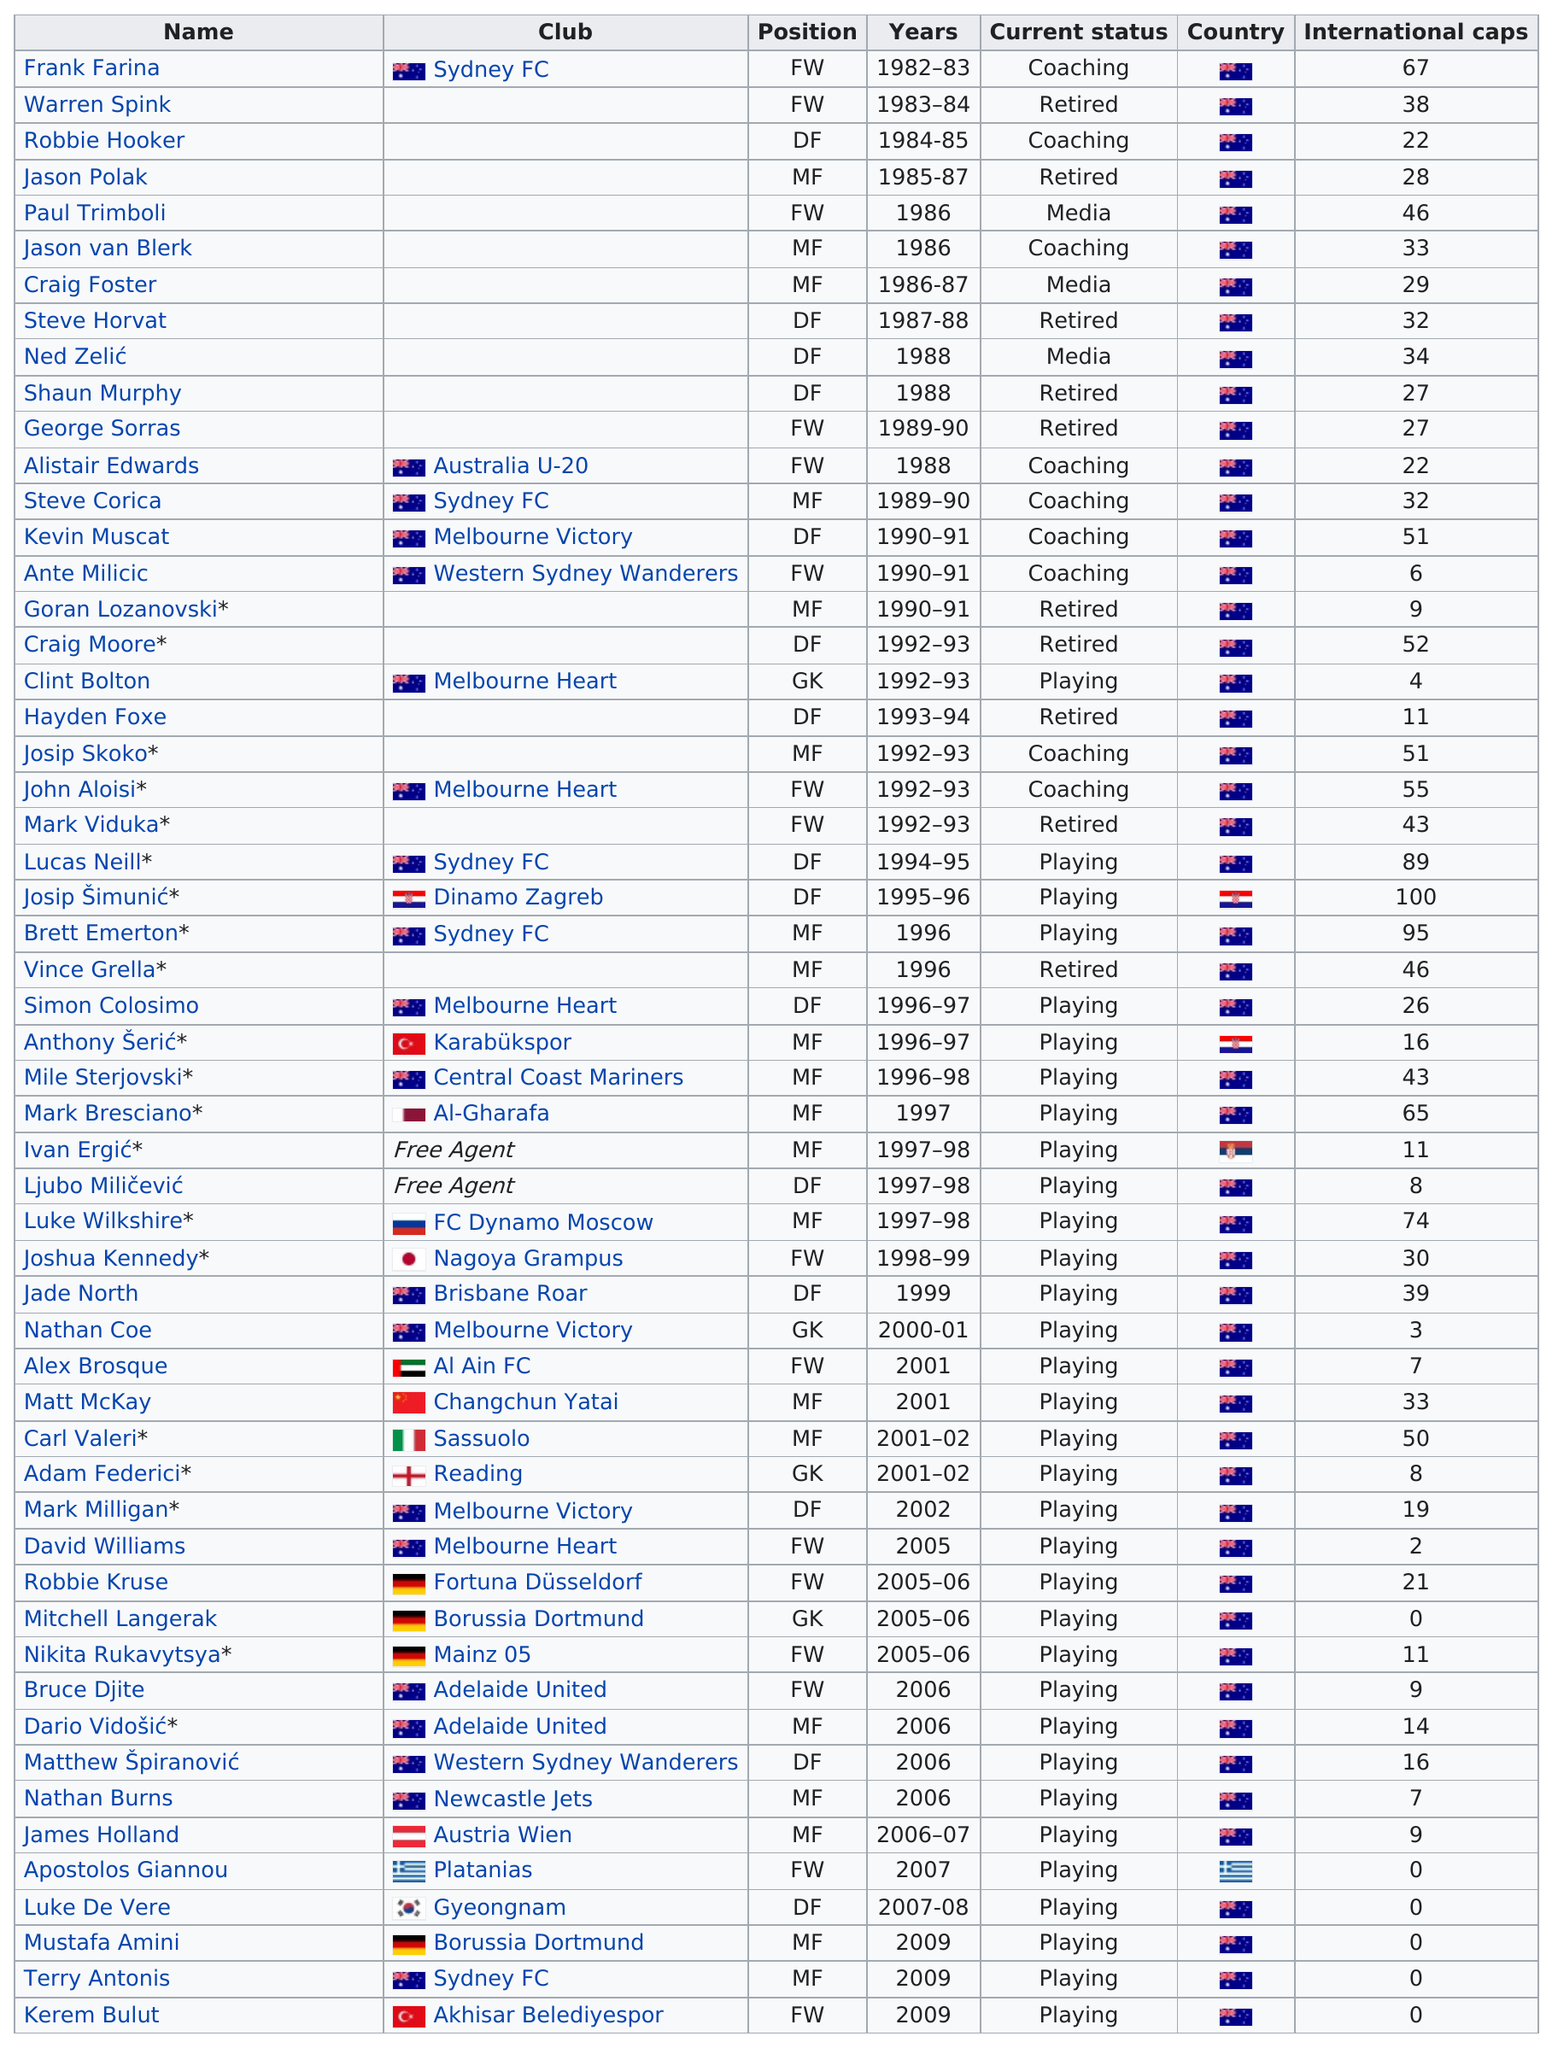Specify some key components in this picture. There were only three notable alumni in the 1990's who did not hail from Australia. Currently, there are 10 retired players. Clint Bolton, an alumni from the 1990's, has the least number of international caps among all his peers. Out of all players, 15 have more than 40 international caps. Dinamo Zagreb has the most international caps among all teams, proving their exceptional talent and global recognition. 